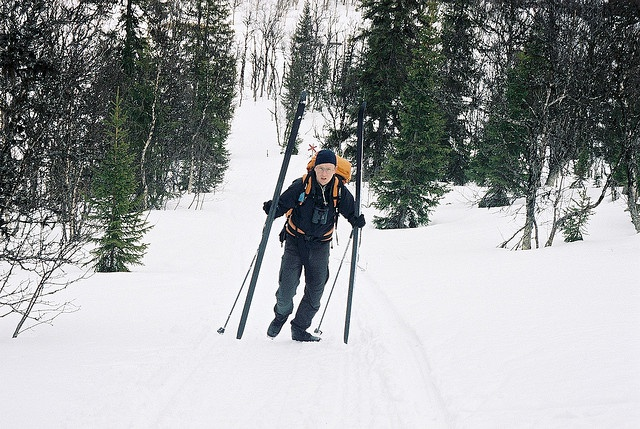Describe the objects in this image and their specific colors. I can see people in darkgray, black, blue, and gray tones, skis in darkgray, black, gray, blue, and darkblue tones, and backpack in darkgray, black, tan, white, and red tones in this image. 